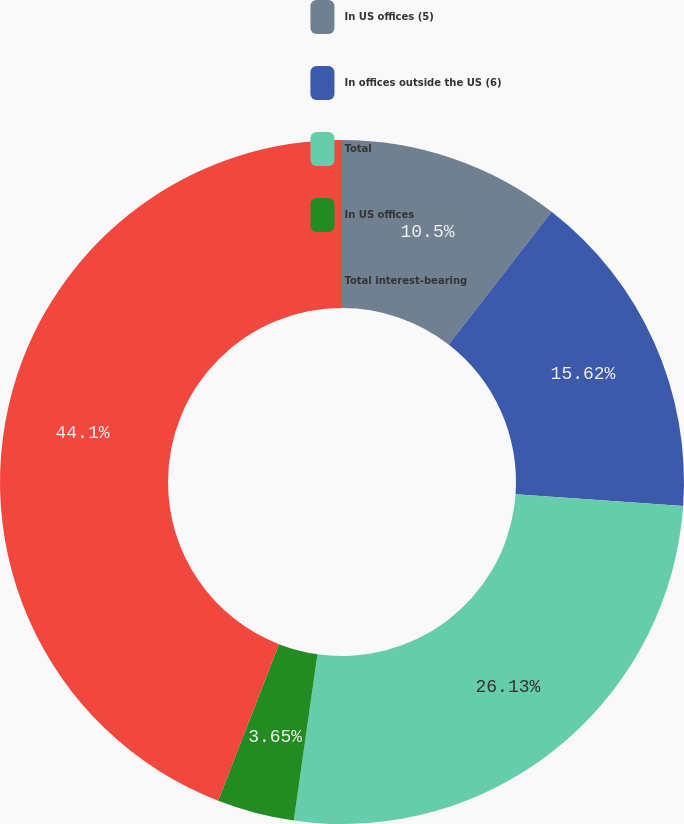<chart> <loc_0><loc_0><loc_500><loc_500><pie_chart><fcel>In US offices (5)<fcel>In offices outside the US (6)<fcel>Total<fcel>In US offices<fcel>Total interest-bearing<nl><fcel>10.5%<fcel>15.62%<fcel>26.13%<fcel>3.65%<fcel>44.1%<nl></chart> 